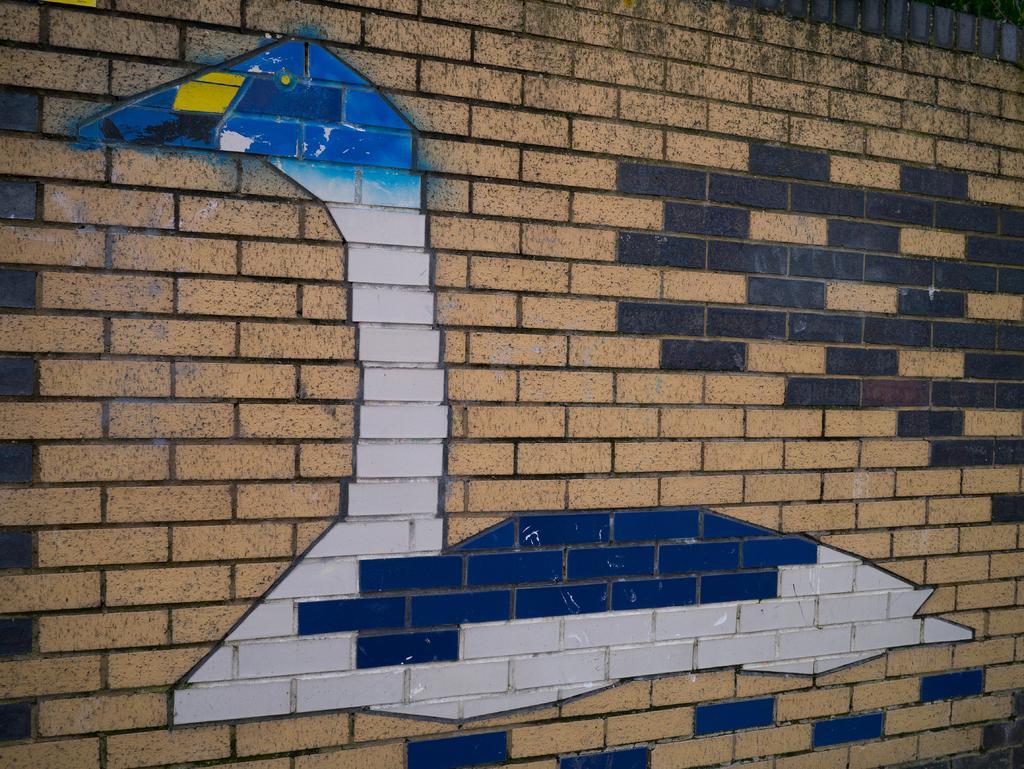Please provide a concise description of this image. In this image there is a brick wall on which there is a painting of a duck with different colors. 